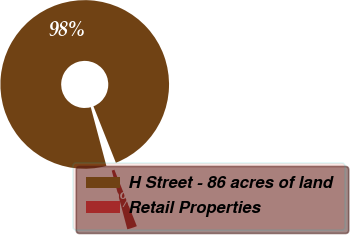Convert chart. <chart><loc_0><loc_0><loc_500><loc_500><pie_chart><fcel>H Street - 86 acres of land<fcel>Retail Properties<nl><fcel>98.11%<fcel>1.89%<nl></chart> 